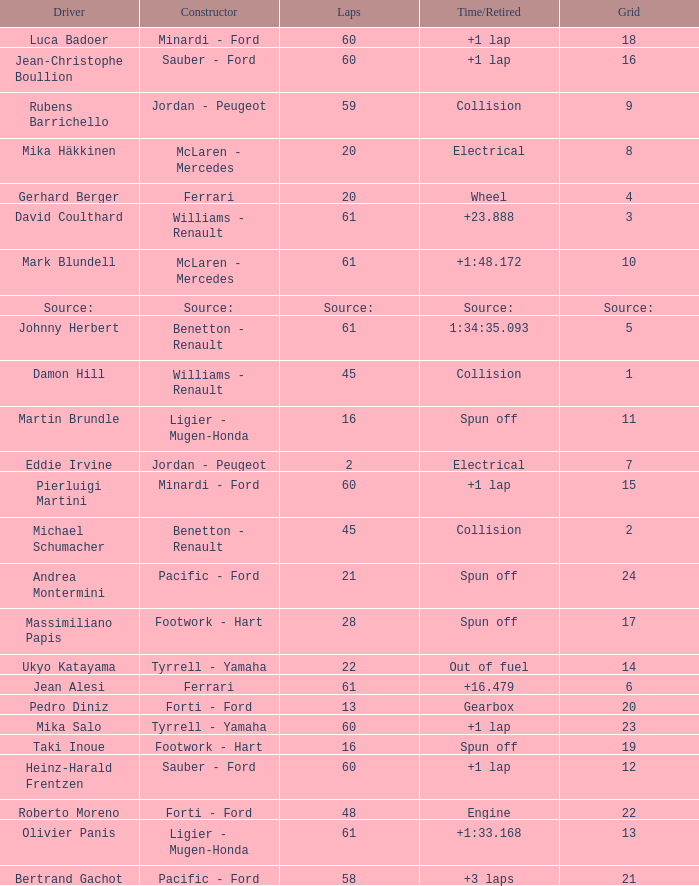What's the time/retired for a grid of 14? Out of fuel. 